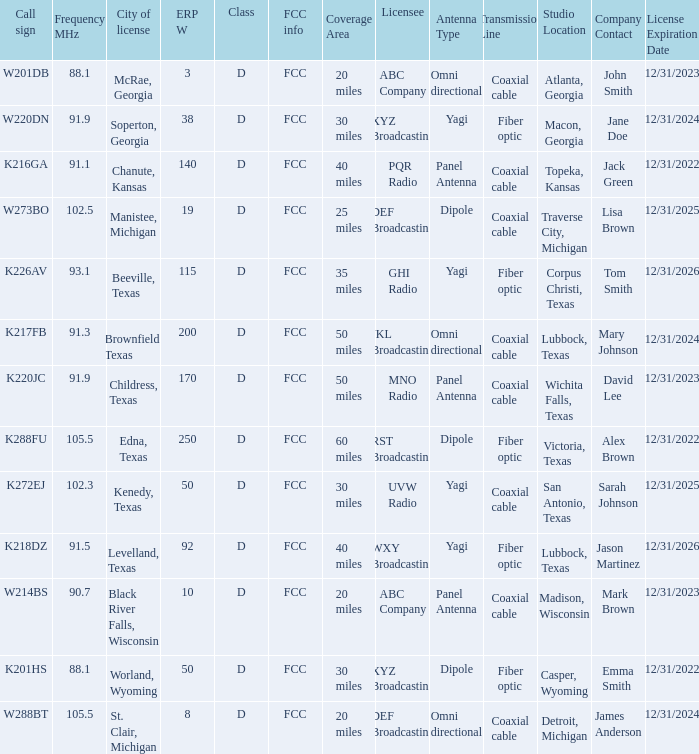What is the Sum of ERP W, when Call Sign is K216GA? 140.0. 